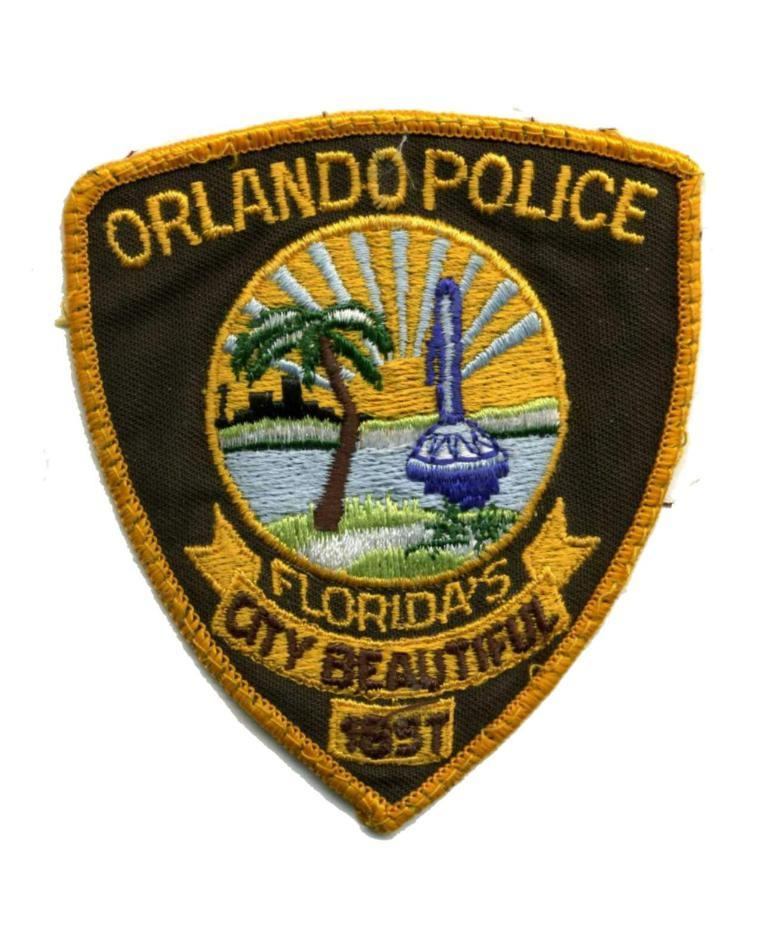What is the main feature of the image? The main feature of the image is a logo. What elements are included in the logo? The logo contains text and pictures. What type of jam is being spread on the teeth in the image? There is no jam or teeth present in the image; it features a logo with text and pictures. 